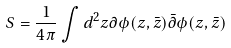<formula> <loc_0><loc_0><loc_500><loc_500>S = \frac { 1 } { 4 \pi } \int d ^ { 2 } z \partial \phi ( z , \bar { z } ) \bar { \partial } \phi ( z , \bar { z } )</formula> 